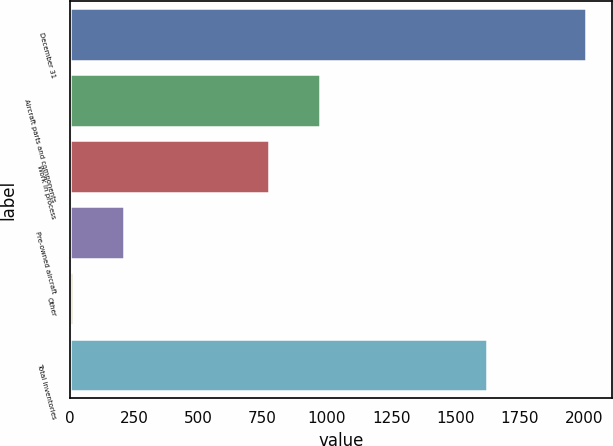Convert chart. <chart><loc_0><loc_0><loc_500><loc_500><bar_chart><fcel>December 31<fcel>Aircraft parts and components<fcel>Work in process<fcel>Pre-owned aircraft<fcel>Other<fcel>Total inventories<nl><fcel>2007<fcel>973.4<fcel>774<fcel>212.4<fcel>13<fcel>1621<nl></chart> 